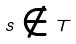Convert formula to latex. <formula><loc_0><loc_0><loc_500><loc_500>s \notin T</formula> 